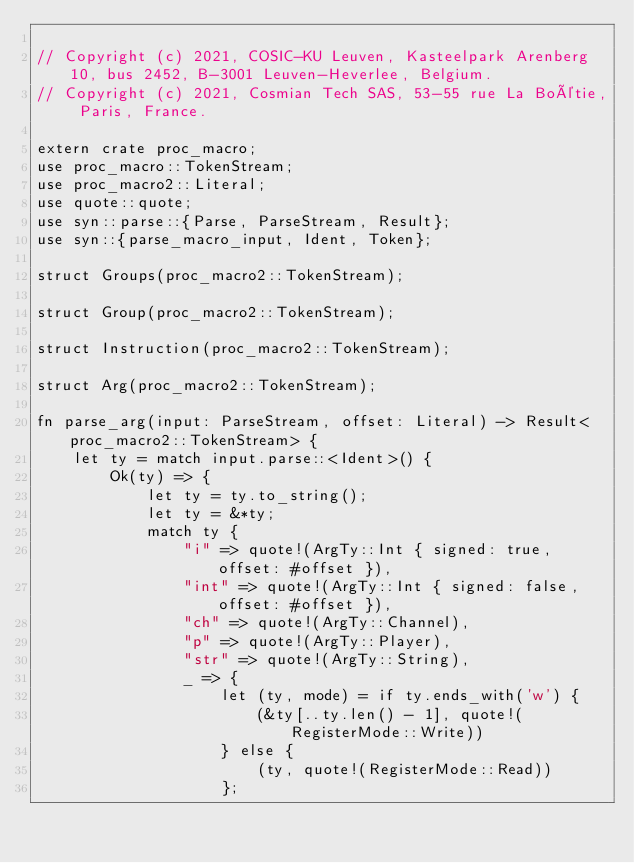<code> <loc_0><loc_0><loc_500><loc_500><_Rust_>
// Copyright (c) 2021, COSIC-KU Leuven, Kasteelpark Arenberg 10, bus 2452, B-3001 Leuven-Heverlee, Belgium.
// Copyright (c) 2021, Cosmian Tech SAS, 53-55 rue La Boétie, Paris, France.

extern crate proc_macro;
use proc_macro::TokenStream;
use proc_macro2::Literal;
use quote::quote;
use syn::parse::{Parse, ParseStream, Result};
use syn::{parse_macro_input, Ident, Token};

struct Groups(proc_macro2::TokenStream);

struct Group(proc_macro2::TokenStream);

struct Instruction(proc_macro2::TokenStream);

struct Arg(proc_macro2::TokenStream);

fn parse_arg(input: ParseStream, offset: Literal) -> Result<proc_macro2::TokenStream> {
    let ty = match input.parse::<Ident>() {
        Ok(ty) => {
            let ty = ty.to_string();
            let ty = &*ty;
            match ty {
                "i" => quote!(ArgTy::Int { signed: true, offset: #offset }),
                "int" => quote!(ArgTy::Int { signed: false, offset: #offset }),
                "ch" => quote!(ArgTy::Channel),
                "p" => quote!(ArgTy::Player),
                "str" => quote!(ArgTy::String),
                _ => {
                    let (ty, mode) = if ty.ends_with('w') {
                        (&ty[..ty.len() - 1], quote!(RegisterMode::Write))
                    } else {
                        (ty, quote!(RegisterMode::Read))
                    };</code> 